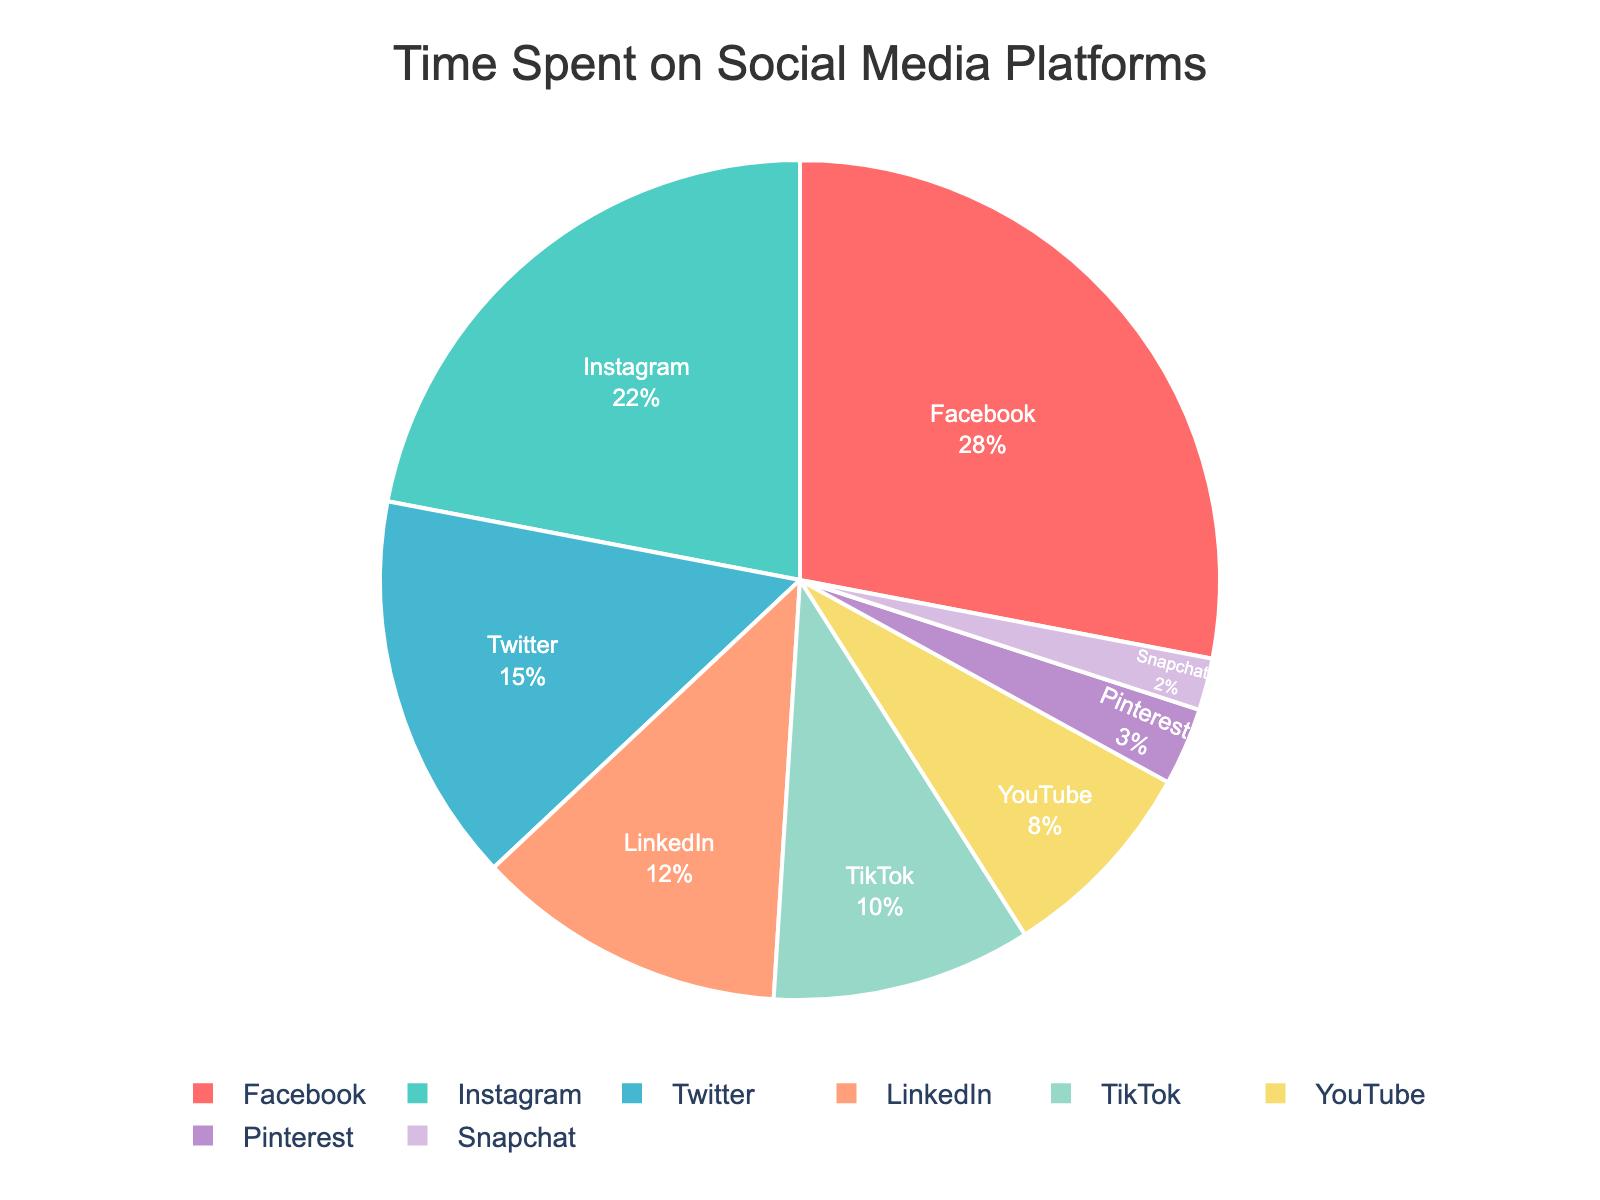What percentage of time is spent on Facebook compared to Instagram? The pie chart shows that 28% of the time is spent on Facebook and 22% on Instagram. To compare these, simply note the two values from the chart.
Answer: 28% vs. 22% Which social media platform has the least amount of time spent on it? By looking at the pie chart, Snapchat has the smallest segment, representing 2% of the time spent.
Answer: Snapchat What is the combined percentage of time spent on Facebook and YouTube? The pie chart indicates 28% of the time is spent on Facebook and 8% on YouTube. Adding these percentages gives 28 + 8 = 36.
Answer: 36% Is the percentage of time spent on LinkedIn greater than that spent on TikTok? According to the pie chart, LinkedIn accounts for 12% of the time spent, whereas TikTok accounts for 10%. Since 12% is greater than 10%, LinkedIn has a higher percentage.
Answer: Yes How much more time, in percentage points, is spent on Facebook compared to Pinterest? The chart shows 28% of the time is spent on Facebook and 3% on Pinterest. Subtracting these values gives 28 - 3 = 25.
Answer: 25% What's the percentage difference between time spent on TikTok and Snapchat? TikTok accounts for 10% of the time spent, and Snapchat for 2%. The difference in percentage is 10 - 2 = 8.
Answer: 8% If we look at the platforms with the top three percentages, what’s their total time spent? The top three platforms by percentage are Facebook (28%), Instagram (22%), and Twitter (15%). Adding these values gives 28 + 22 + 15 = 65.
Answer: 65% Which platform has a larger share of time, Pinterest or YouTube, and by how much? The pie chart shows YouTube at 8% and Pinterest at 3%. YouTube's share is larger. The difference is 8 - 3 = 5 percentage points.
Answer: YouTube by 5% Which three platforms have the smallest combined percentage of time spent? The three platforms with the smallest percentages are Pinterest (3%), Snapchat (2%), and YouTube (8%). Adding these values gives 3 + 2 + 8 = 13.
Answer: Pinterest, Snapchat, and YouTube; 13% What is the average percentage of time spent on Twitter and LinkedIn? Twitter's percentage is 15% and LinkedIn’s is 12%. Average these two values by adding them and dividing by 2: (15 + 12) / 2 = 13.5.
Answer: 13.5% 